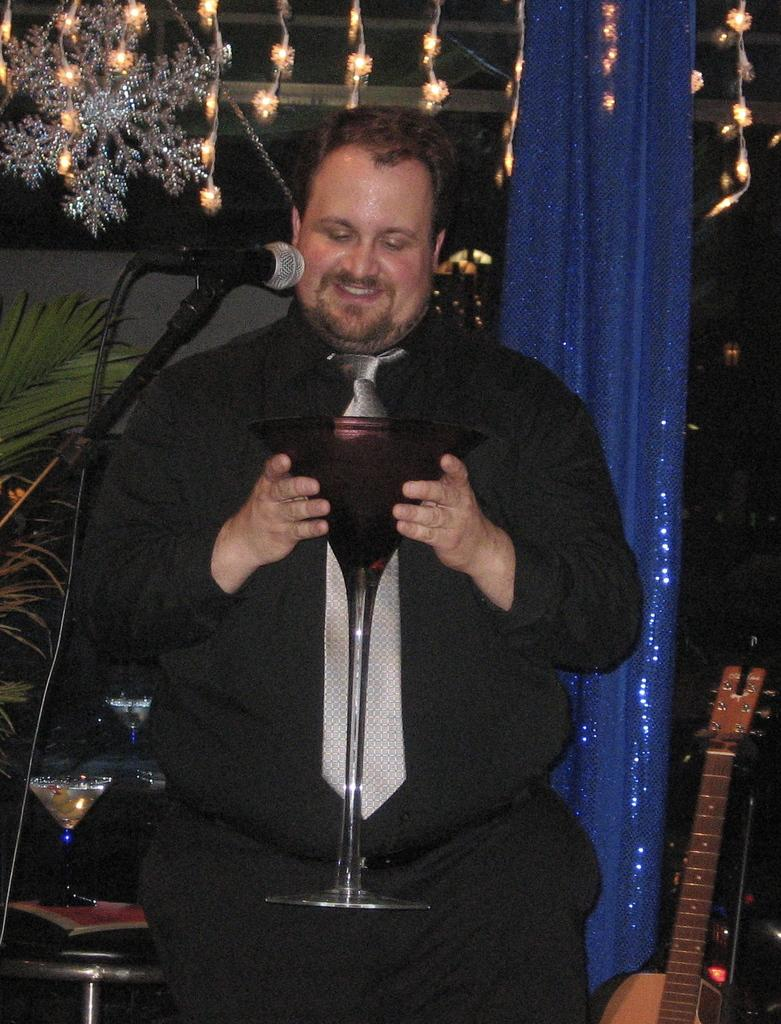What is the main subject of the image? There is a person in the image. What is the person holding in the image? The person is holding a big glass. What can be seen behind the person? There is a blue curtain, a plant, and lights visible in the background. What object is at the side of the person? There is a guitar at the side of the person. What is the person standing in front of? The person is in front of a mic. What degree does the person have in the image? There is no information about the person's degree in the image. Is the person stuck in quicksand in the image? There is no quicksand present in the image. 